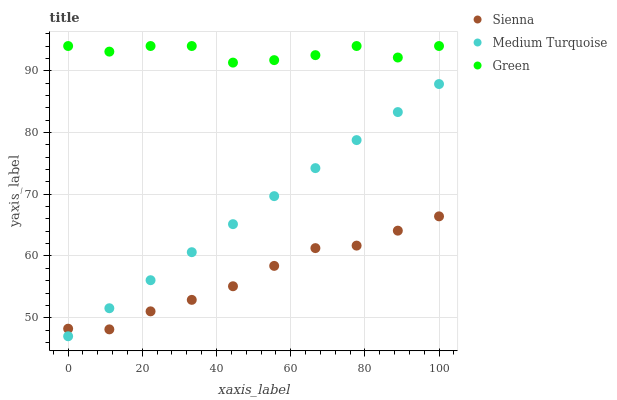Does Sienna have the minimum area under the curve?
Answer yes or no. Yes. Does Green have the maximum area under the curve?
Answer yes or no. Yes. Does Medium Turquoise have the minimum area under the curve?
Answer yes or no. No. Does Medium Turquoise have the maximum area under the curve?
Answer yes or no. No. Is Medium Turquoise the smoothest?
Answer yes or no. Yes. Is Green the roughest?
Answer yes or no. Yes. Is Green the smoothest?
Answer yes or no. No. Is Medium Turquoise the roughest?
Answer yes or no. No. Does Medium Turquoise have the lowest value?
Answer yes or no. Yes. Does Green have the lowest value?
Answer yes or no. No. Does Green have the highest value?
Answer yes or no. Yes. Does Medium Turquoise have the highest value?
Answer yes or no. No. Is Medium Turquoise less than Green?
Answer yes or no. Yes. Is Green greater than Medium Turquoise?
Answer yes or no. Yes. Does Medium Turquoise intersect Sienna?
Answer yes or no. Yes. Is Medium Turquoise less than Sienna?
Answer yes or no. No. Is Medium Turquoise greater than Sienna?
Answer yes or no. No. Does Medium Turquoise intersect Green?
Answer yes or no. No. 